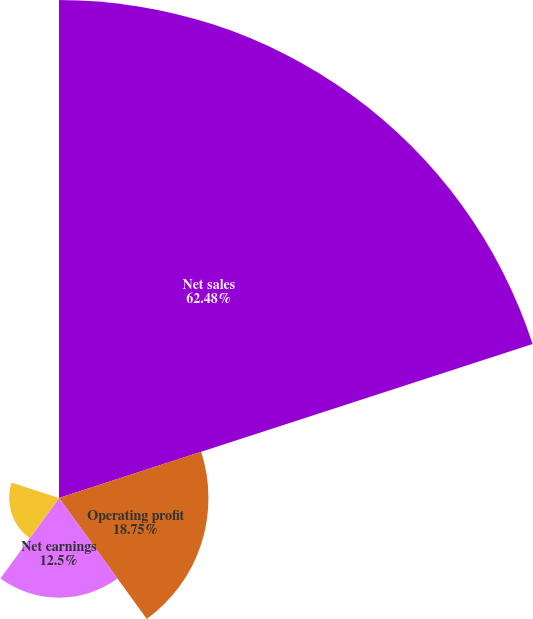<chart> <loc_0><loc_0><loc_500><loc_500><pie_chart><fcel>Net sales<fcel>Operating profit<fcel>Net earnings<fcel>Basic earnings per share<fcel>Diluted earnings per share<nl><fcel>62.48%<fcel>18.75%<fcel>12.5%<fcel>6.26%<fcel>0.01%<nl></chart> 